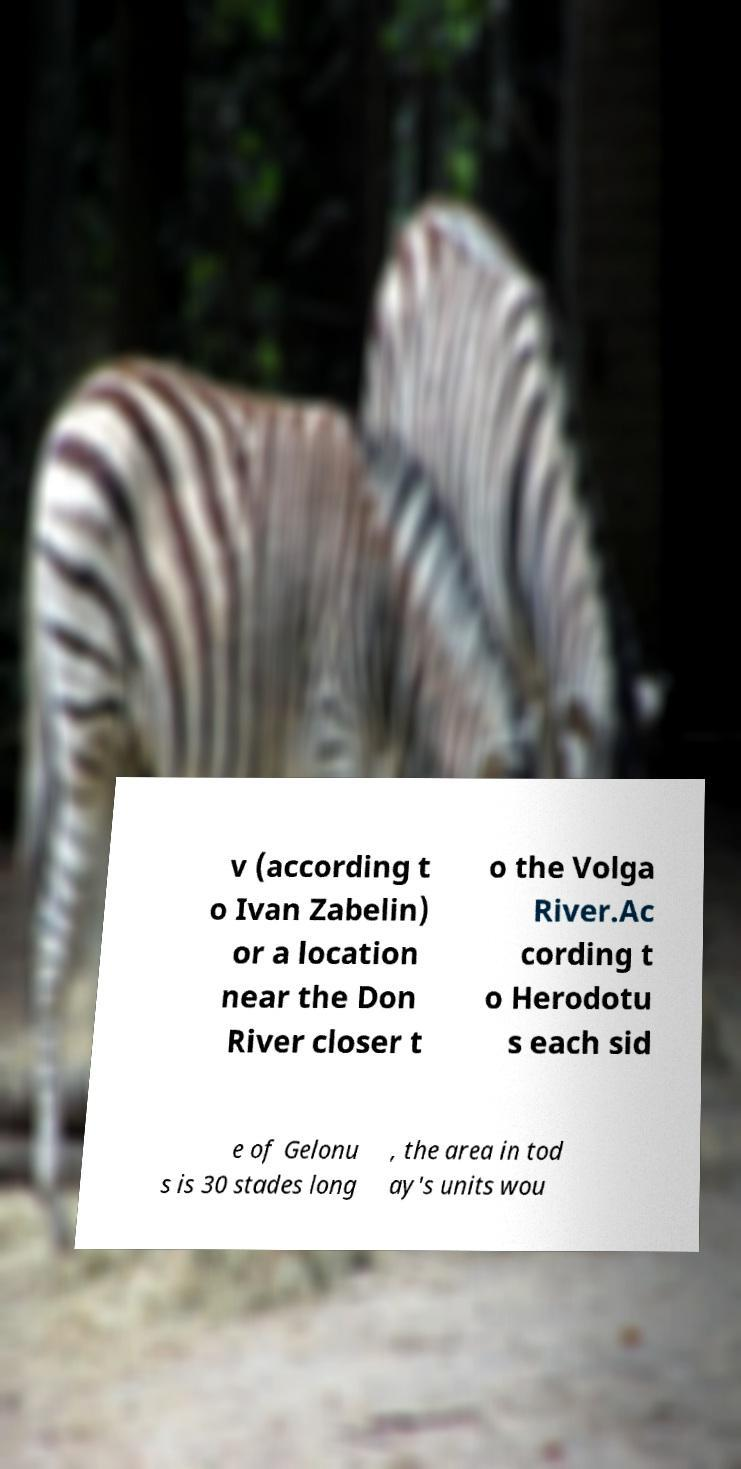For documentation purposes, I need the text within this image transcribed. Could you provide that? v (according t o Ivan Zabelin) or a location near the Don River closer t o the Volga River.Ac cording t o Herodotu s each sid e of Gelonu s is 30 stades long , the area in tod ay's units wou 